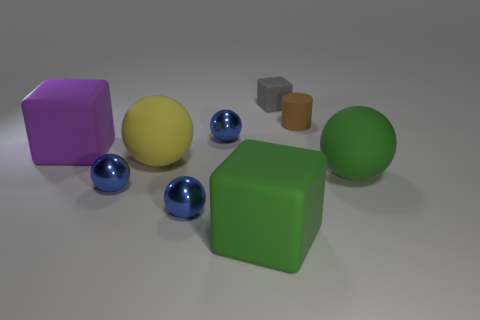Pretend these objects have personalities. What might they say to each other? If these objects had personalities, one might imagine the blue spheres joking about rolling around with ease, while the large green cube responds with a playful quip about being the 'foundation' of stability in their group. The yellow sphere may chime in, bragging about its striking color and how it stands out, whereas the smaller, more ordinary looking shapes might talk about the value of subtlety and understatement. 